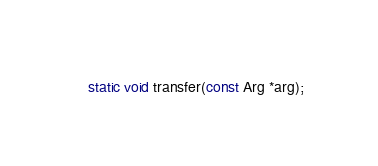Convert code to text. <code><loc_0><loc_0><loc_500><loc_500><_C_>static void transfer(const Arg *arg);

</code> 